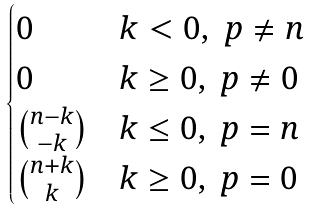Convert formula to latex. <formula><loc_0><loc_0><loc_500><loc_500>\begin{cases} 0 & k < 0 , \ p \ne n \\ 0 & k \geq 0 , \ p \ne 0 \\ \binom { n - k } { - k } & k \leq 0 , \ p = n \\ \binom { n + k } { k } & k \geq 0 , \ p = 0 \end{cases}</formula> 